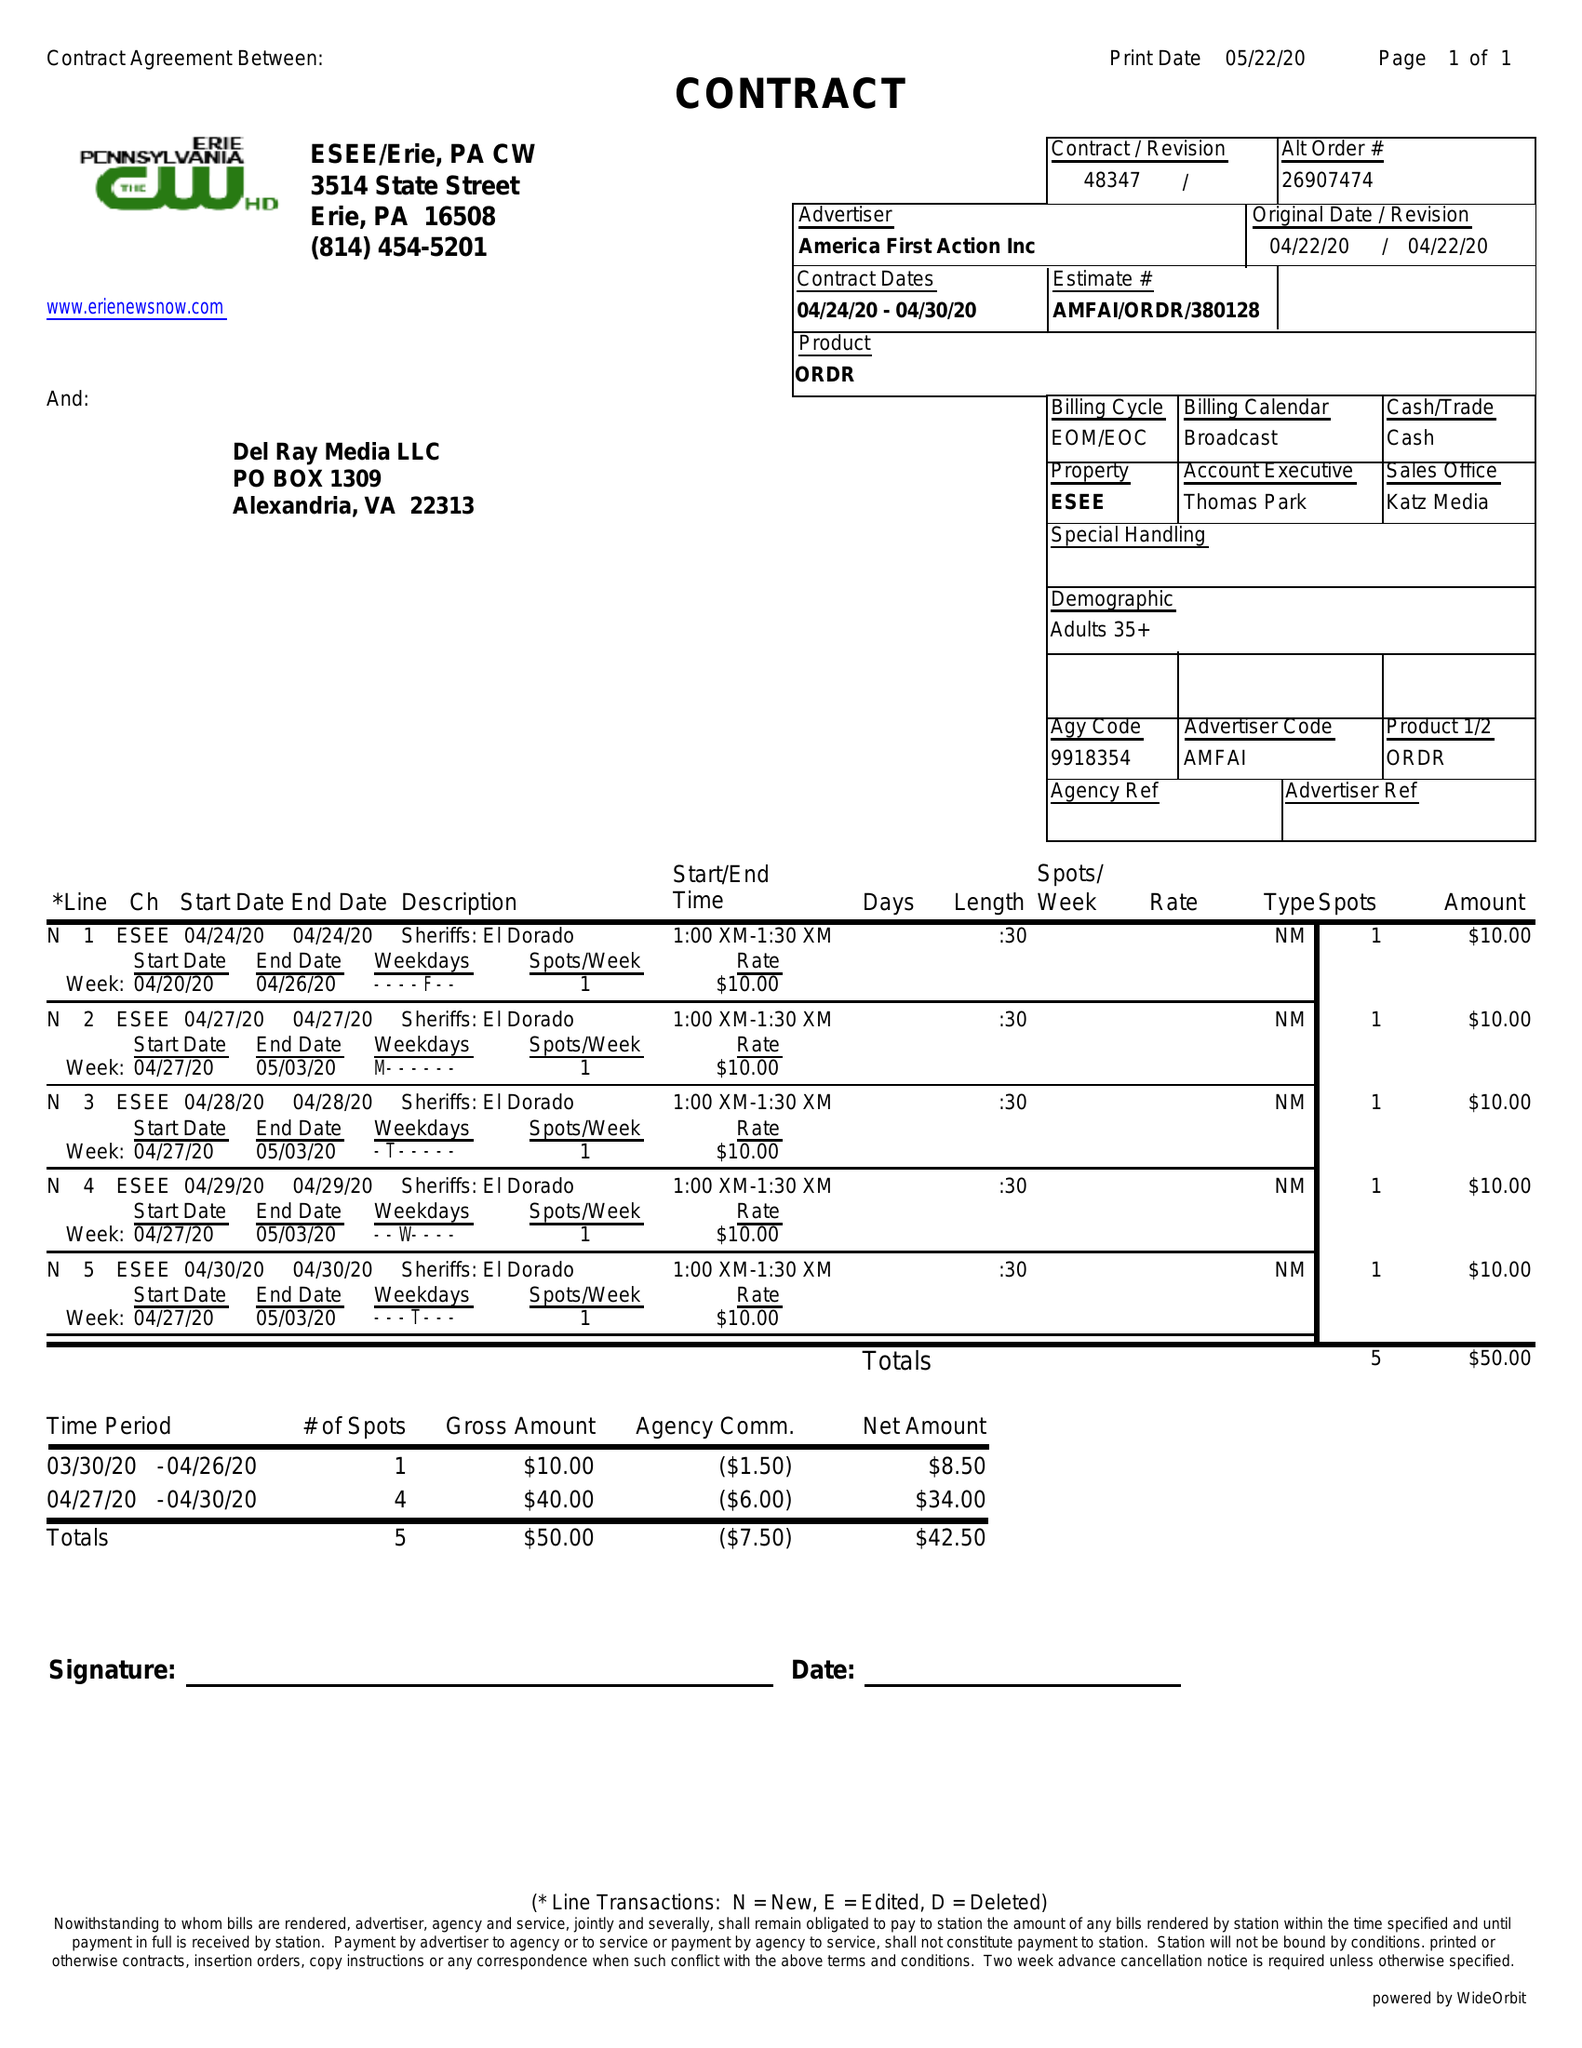What is the value for the advertiser?
Answer the question using a single word or phrase. AMERICA FIRST ACTION INC 